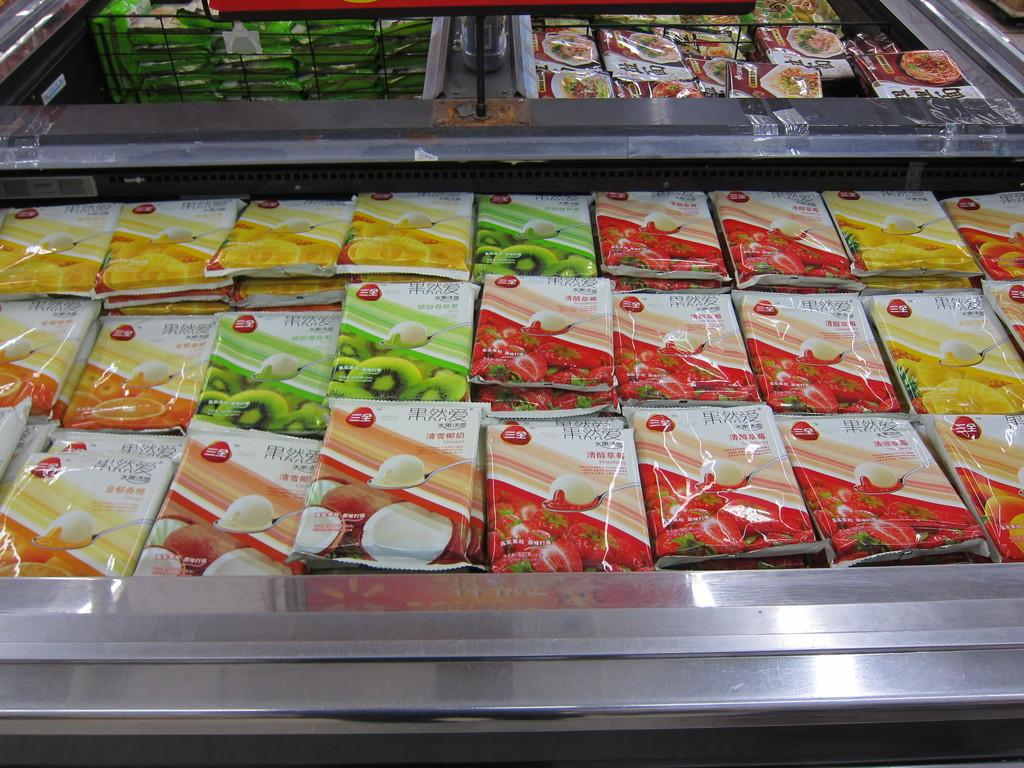What is located in the foreground of the image? There are packets of food in the foreground of the image. What can be seen on the packets of food? The packets of food have images of fruits on them. What is visible in the background of the image? In the background, there are more packs in baskets. How do the fairies contribute to the profit of the food packets in the image? There are no fairies present in the image, and therefore their contribution to the profit of the food packets cannot be determined. 